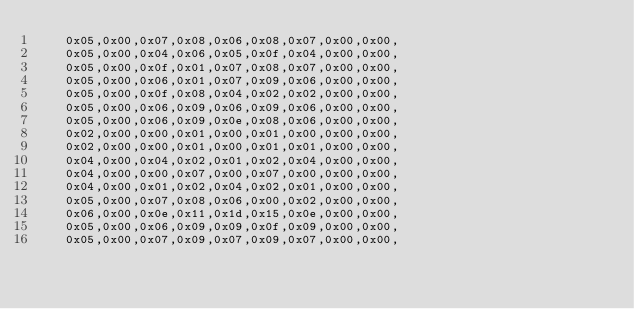Convert code to text. <code><loc_0><loc_0><loc_500><loc_500><_C_>    0x05,0x00,0x07,0x08,0x06,0x08,0x07,0x00,0x00,
    0x05,0x00,0x04,0x06,0x05,0x0f,0x04,0x00,0x00,
    0x05,0x00,0x0f,0x01,0x07,0x08,0x07,0x00,0x00,
    0x05,0x00,0x06,0x01,0x07,0x09,0x06,0x00,0x00,
    0x05,0x00,0x0f,0x08,0x04,0x02,0x02,0x00,0x00,
    0x05,0x00,0x06,0x09,0x06,0x09,0x06,0x00,0x00,
    0x05,0x00,0x06,0x09,0x0e,0x08,0x06,0x00,0x00,
    0x02,0x00,0x00,0x01,0x00,0x01,0x00,0x00,0x00,
    0x02,0x00,0x00,0x01,0x00,0x01,0x01,0x00,0x00,
    0x04,0x00,0x04,0x02,0x01,0x02,0x04,0x00,0x00,
    0x04,0x00,0x00,0x07,0x00,0x07,0x00,0x00,0x00,
    0x04,0x00,0x01,0x02,0x04,0x02,0x01,0x00,0x00,
    0x05,0x00,0x07,0x08,0x06,0x00,0x02,0x00,0x00,
    0x06,0x00,0x0e,0x11,0x1d,0x15,0x0e,0x00,0x00,
    0x05,0x00,0x06,0x09,0x09,0x0f,0x09,0x00,0x00,
    0x05,0x00,0x07,0x09,0x07,0x09,0x07,0x00,0x00,</code> 